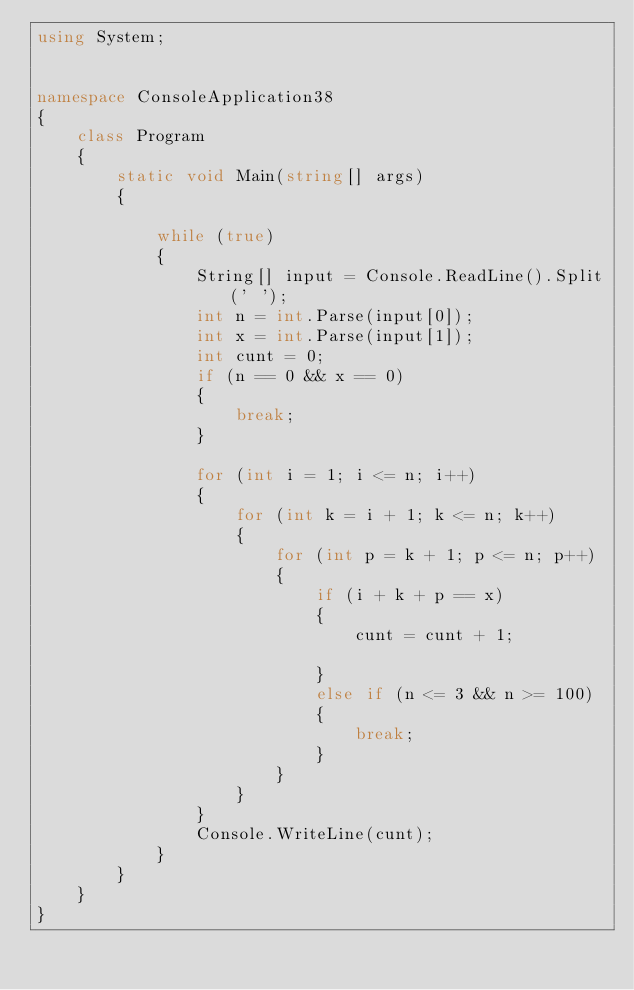<code> <loc_0><loc_0><loc_500><loc_500><_C#_>using System;


namespace ConsoleApplication38
{
    class Program
    {
        static void Main(string[] args)
        {
            
            while (true)
            {
                String[] input = Console.ReadLine().Split(' ');
                int n = int.Parse(input[0]);
                int x = int.Parse(input[1]);
                int cunt = 0;
                if (n == 0 && x == 0)
                {
                    break;
                }

                for (int i = 1; i <= n; i++)
                {
                    for (int k = i + 1; k <= n; k++)
                    {
                        for (int p = k + 1; p <= n; p++)
                        {
                            if (i + k + p == x)
                            {
                                cunt = cunt + 1;
                                
                            }
                            else if (n <= 3 && n >= 100)
                            {
                                break;
                            }
                        }
                    }
                }
                Console.WriteLine(cunt);
            }
        }
    }
}</code> 